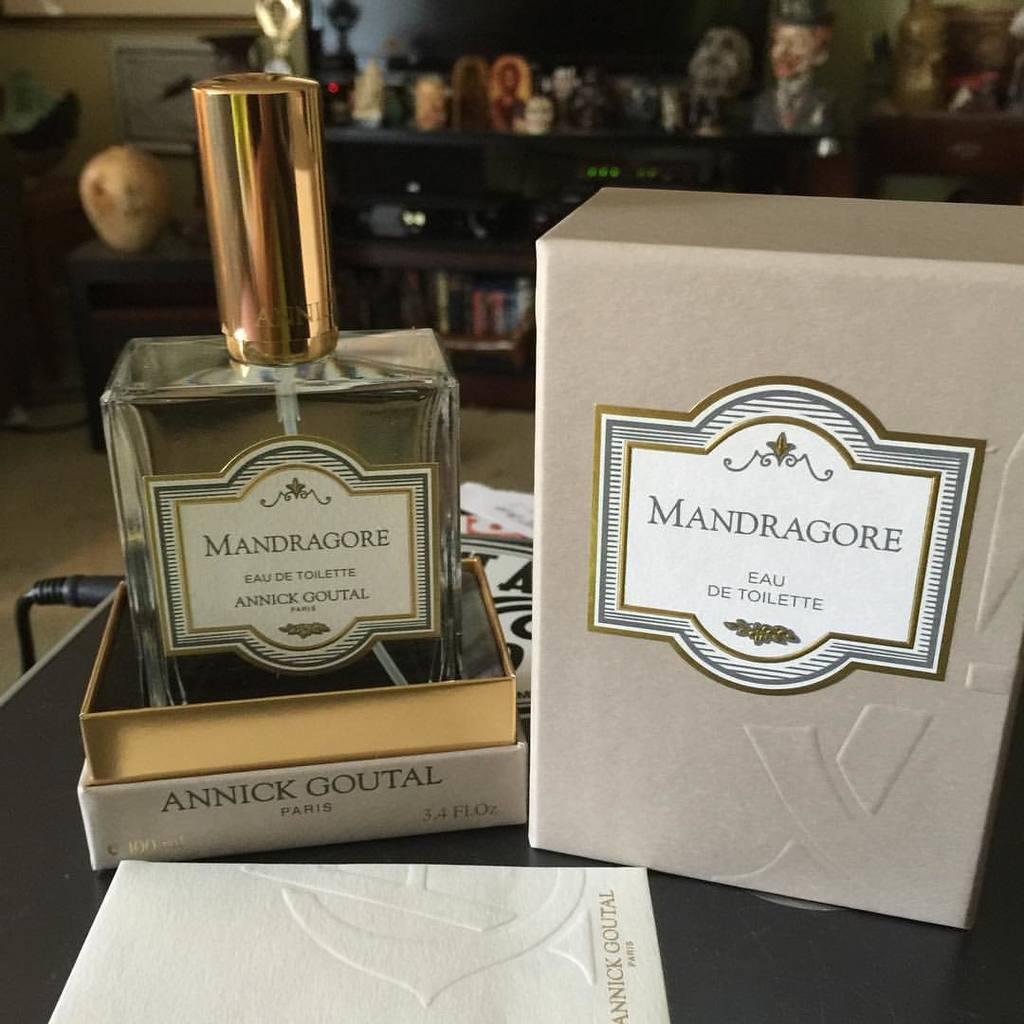What city is this eau de toilette from?
Offer a very short reply. Paris. What brand is the cologne?
Offer a terse response. Mandragore. 